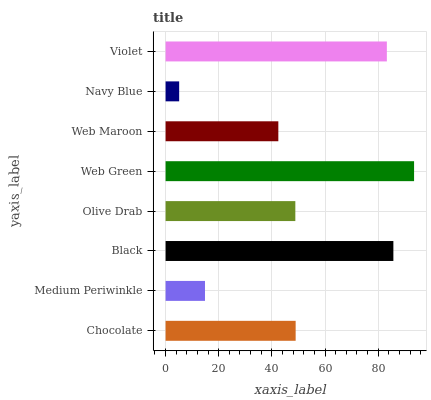Is Navy Blue the minimum?
Answer yes or no. Yes. Is Web Green the maximum?
Answer yes or no. Yes. Is Medium Periwinkle the minimum?
Answer yes or no. No. Is Medium Periwinkle the maximum?
Answer yes or no. No. Is Chocolate greater than Medium Periwinkle?
Answer yes or no. Yes. Is Medium Periwinkle less than Chocolate?
Answer yes or no. Yes. Is Medium Periwinkle greater than Chocolate?
Answer yes or no. No. Is Chocolate less than Medium Periwinkle?
Answer yes or no. No. Is Chocolate the high median?
Answer yes or no. Yes. Is Olive Drab the low median?
Answer yes or no. Yes. Is Violet the high median?
Answer yes or no. No. Is Web Maroon the low median?
Answer yes or no. No. 